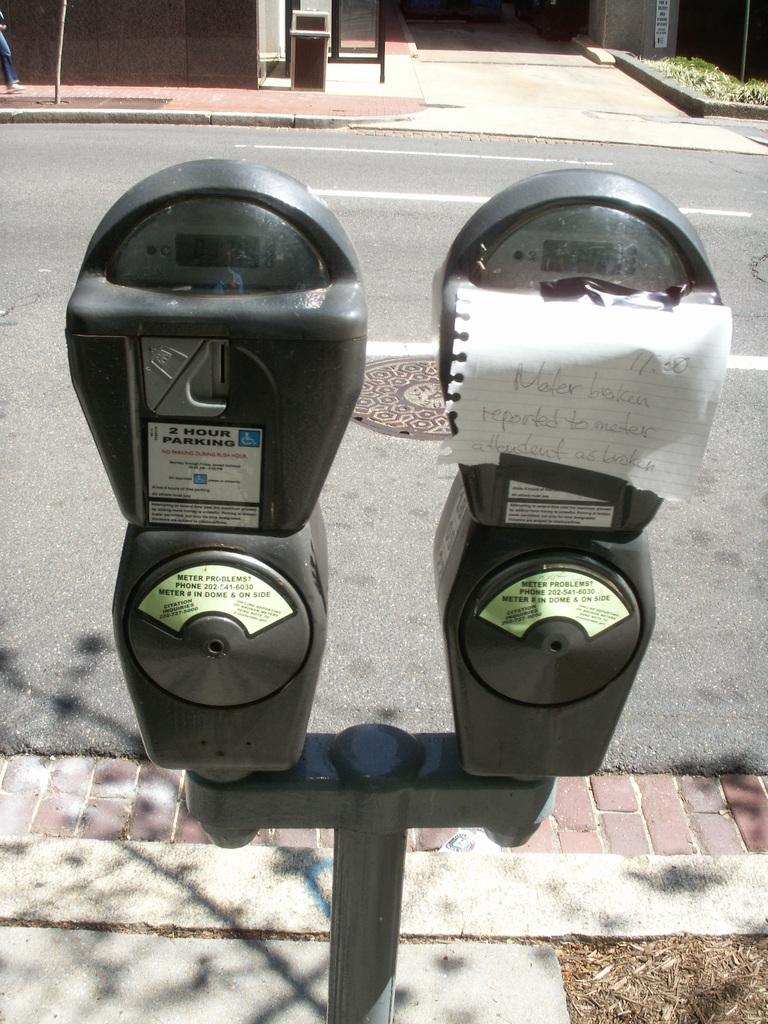<image>
Give a short and clear explanation of the subsequent image. A piece of paper reading "meter broken" has been taped over a sidewalk meter 